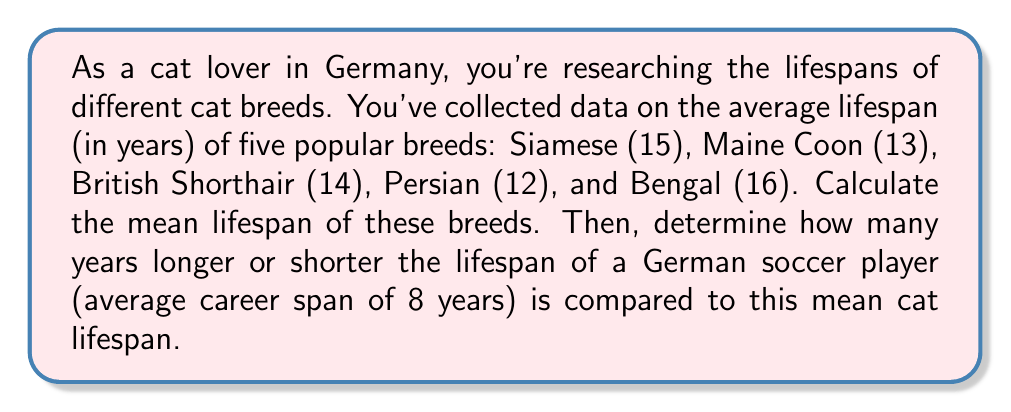Provide a solution to this math problem. Let's approach this problem step by step:

1. Calculate the mean lifespan of the cat breeds:
   
   Mean = $\frac{\text{Sum of all values}}{\text{Number of values}}$

   $\text{Sum} = 15 + 13 + 14 + 12 + 16 = 70$ years
   $\text{Number of breeds} = 5$

   Mean lifespan = $\frac{70}{5} = 14$ years

2. Compare the mean cat lifespan to the average career span of a German soccer player:

   Difference = Mean cat lifespan - Average soccer career span
               = $14 - 8 = 6$ years

Therefore, the mean cat lifespan is 6 years longer than the average career span of a German soccer player.
Answer: The mean lifespan of the cat breeds is 14 years, which is 6 years longer than the average career span of a German soccer player. 